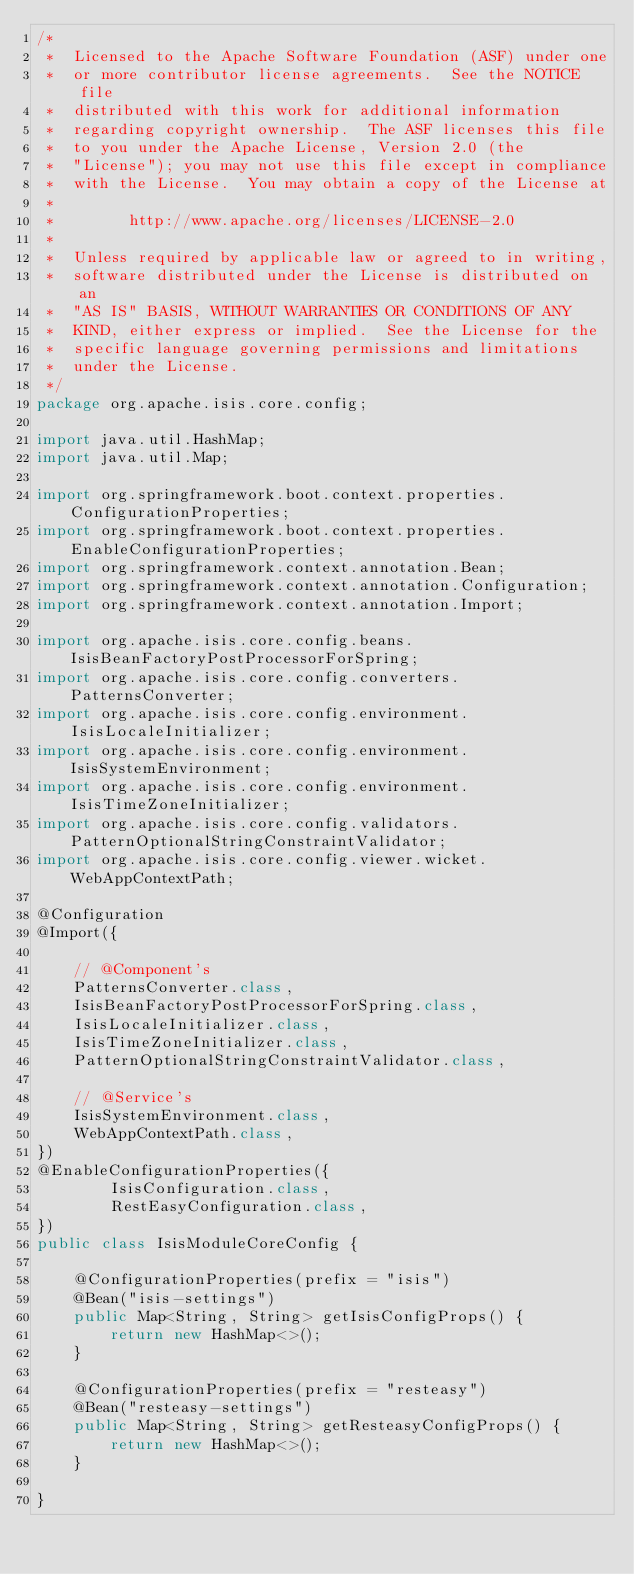<code> <loc_0><loc_0><loc_500><loc_500><_Java_>/*
 *  Licensed to the Apache Software Foundation (ASF) under one
 *  or more contributor license agreements.  See the NOTICE file
 *  distributed with this work for additional information
 *  regarding copyright ownership.  The ASF licenses this file
 *  to you under the Apache License, Version 2.0 (the
 *  "License"); you may not use this file except in compliance
 *  with the License.  You may obtain a copy of the License at
 *
 *        http://www.apache.org/licenses/LICENSE-2.0
 *
 *  Unless required by applicable law or agreed to in writing,
 *  software distributed under the License is distributed on an
 *  "AS IS" BASIS, WITHOUT WARRANTIES OR CONDITIONS OF ANY
 *  KIND, either express or implied.  See the License for the
 *  specific language governing permissions and limitations
 *  under the License.
 */
package org.apache.isis.core.config;

import java.util.HashMap;
import java.util.Map;

import org.springframework.boot.context.properties.ConfigurationProperties;
import org.springframework.boot.context.properties.EnableConfigurationProperties;
import org.springframework.context.annotation.Bean;
import org.springframework.context.annotation.Configuration;
import org.springframework.context.annotation.Import;

import org.apache.isis.core.config.beans.IsisBeanFactoryPostProcessorForSpring;
import org.apache.isis.core.config.converters.PatternsConverter;
import org.apache.isis.core.config.environment.IsisLocaleInitializer;
import org.apache.isis.core.config.environment.IsisSystemEnvironment;
import org.apache.isis.core.config.environment.IsisTimeZoneInitializer;
import org.apache.isis.core.config.validators.PatternOptionalStringConstraintValidator;
import org.apache.isis.core.config.viewer.wicket.WebAppContextPath;

@Configuration
@Import({

    // @Component's
    PatternsConverter.class,
    IsisBeanFactoryPostProcessorForSpring.class,
    IsisLocaleInitializer.class,
    IsisTimeZoneInitializer.class,
    PatternOptionalStringConstraintValidator.class,

    // @Service's
    IsisSystemEnvironment.class,
    WebAppContextPath.class,
})
@EnableConfigurationProperties({
        IsisConfiguration.class,
        RestEasyConfiguration.class,
})
public class IsisModuleCoreConfig {
    
    @ConfigurationProperties(prefix = "isis")
    @Bean("isis-settings")
    public Map<String, String> getIsisConfigProps() {
        return new HashMap<>();
    }

    @ConfigurationProperties(prefix = "resteasy")
    @Bean("resteasy-settings")
    public Map<String, String> getResteasyConfigProps() {
        return new HashMap<>();
    }

}
</code> 